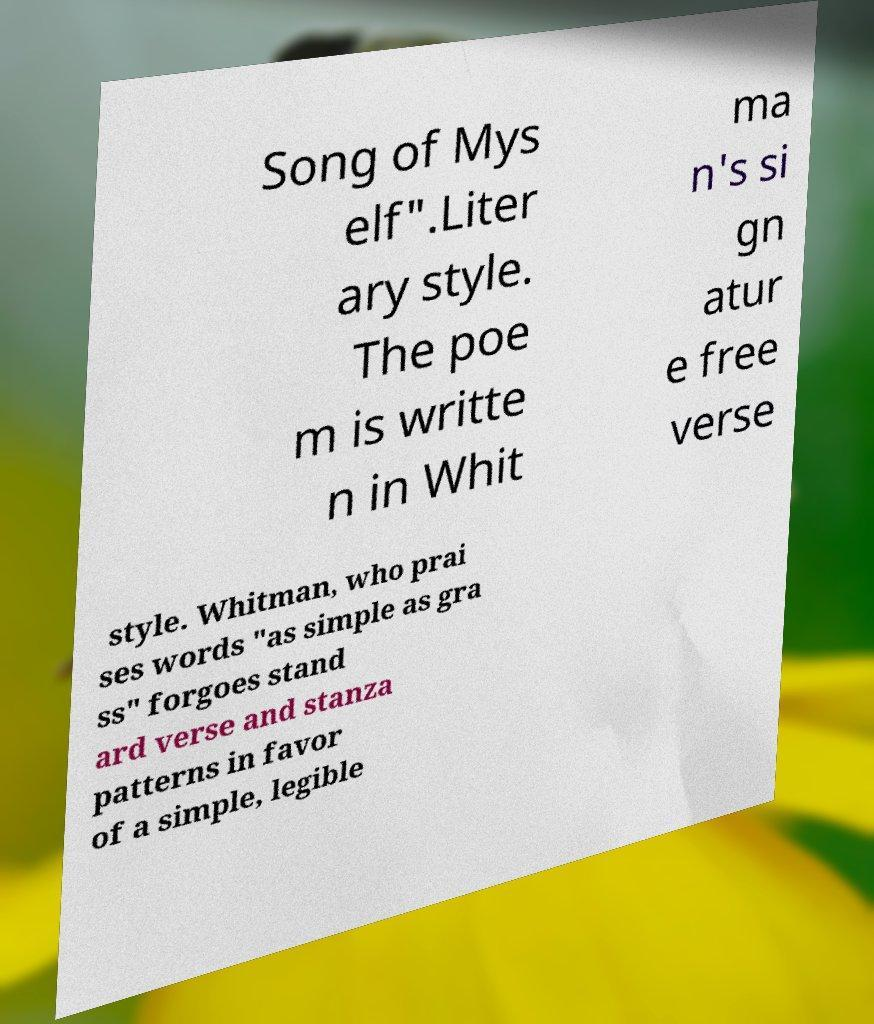Can you read and provide the text displayed in the image?This photo seems to have some interesting text. Can you extract and type it out for me? Song of Mys elf".Liter ary style. The poe m is writte n in Whit ma n's si gn atur e free verse style. Whitman, who prai ses words "as simple as gra ss" forgoes stand ard verse and stanza patterns in favor of a simple, legible 